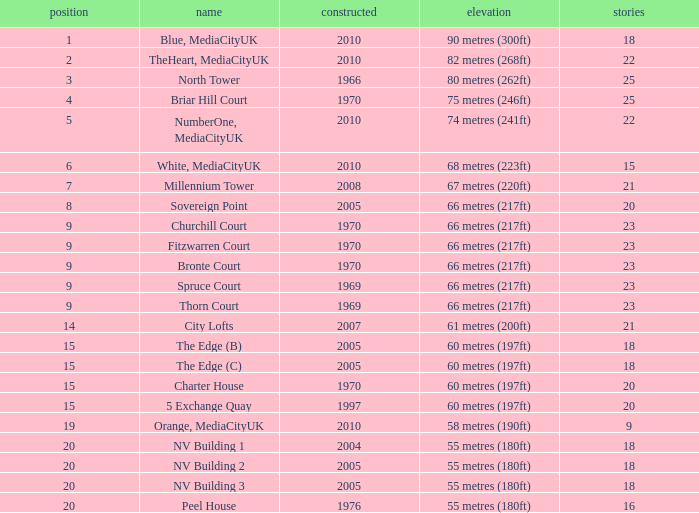What is the lowest Floors, when Built is greater than 1970, and when Name is NV Building 3? 18.0. 